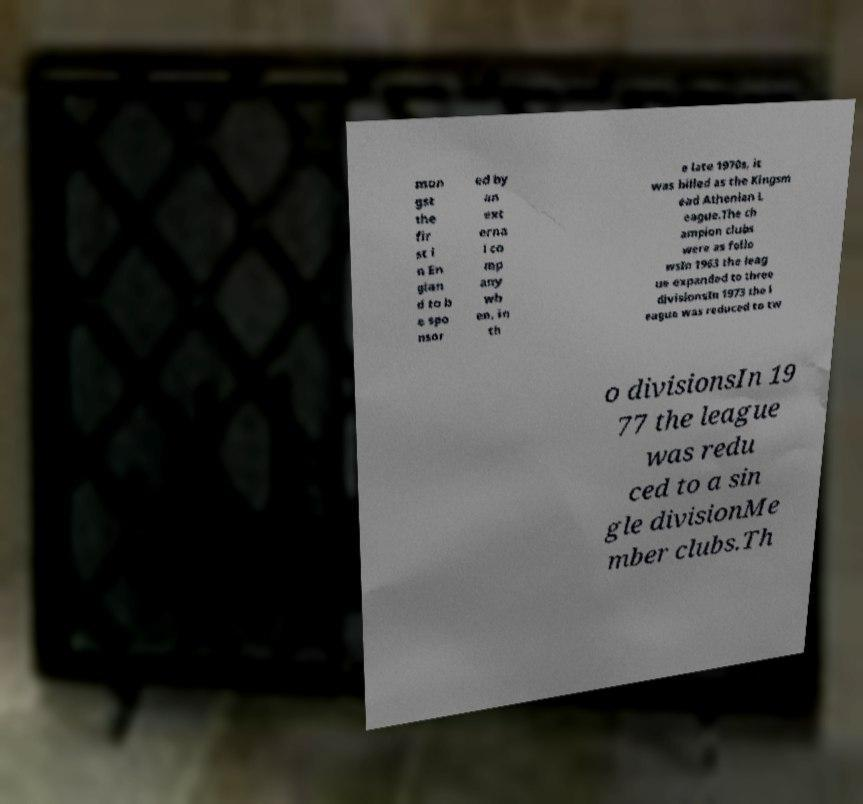Please identify and transcribe the text found in this image. mon gst the fir st i n En glan d to b e spo nsor ed by an ext erna l co mp any wh en, in th e late 1970s, it was billed as the Kingsm ead Athenian L eague.The ch ampion clubs were as follo wsIn 1963 the leag ue expanded to three divisionsIn 1973 the l eague was reduced to tw o divisionsIn 19 77 the league was redu ced to a sin gle divisionMe mber clubs.Th 